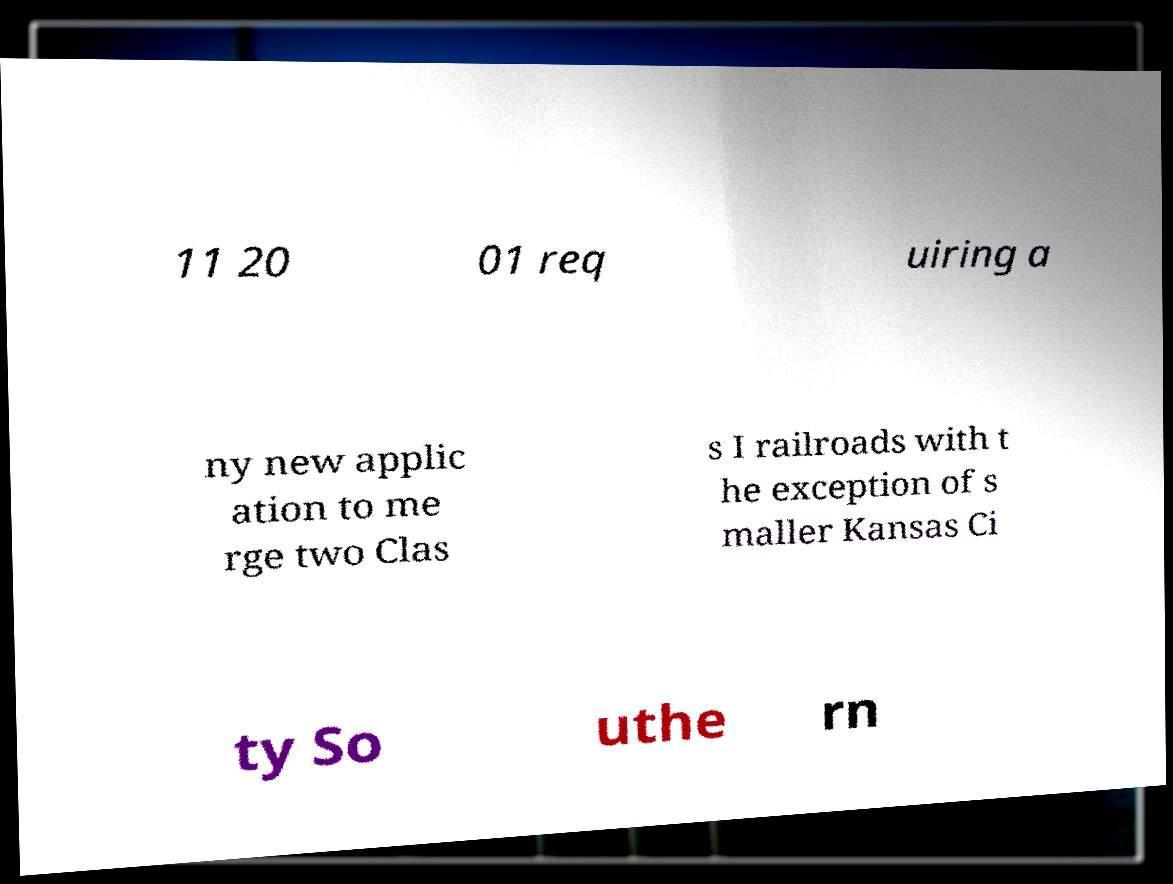Can you read and provide the text displayed in the image?This photo seems to have some interesting text. Can you extract and type it out for me? 11 20 01 req uiring a ny new applic ation to me rge two Clas s I railroads with t he exception of s maller Kansas Ci ty So uthe rn 